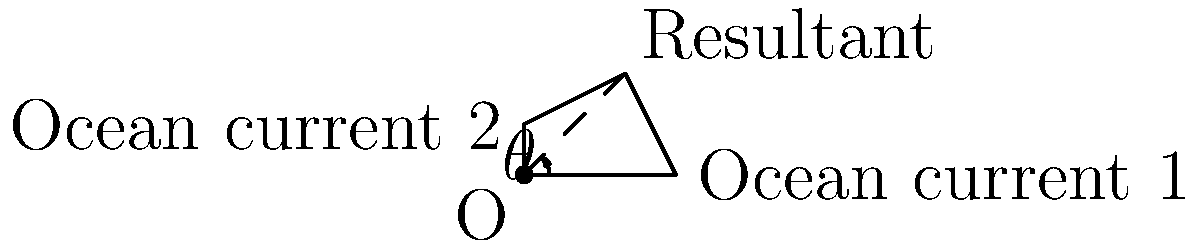Two ocean currents are affecting the migration pattern of a marine species. Current 1 has a force of 30 N due east, while Current 2 has a force of 20 N due north. Calculate the magnitude and direction of the resultant force influencing the marine animals' movement. To solve this problem, we'll use vector addition and the Pythagorean theorem:

1. Represent the currents as vectors:
   Current 1: $\vec{F_1} = 30\hat{i}$ N
   Current 2: $\vec{F_2} = 20\hat{j}$ N

2. The resultant force $\vec{R}$ is the vector sum:
   $\vec{R} = \vec{F_1} + \vec{F_2} = 30\hat{i} + 20\hat{j}$ N

3. Calculate the magnitude of the resultant force using the Pythagorean theorem:
   $|\vec{R}| = \sqrt{30^2 + 20^2} = \sqrt{1300} \approx 36.06$ N

4. Calculate the direction (angle $\theta$) using the arctangent function:
   $\theta = \tan^{-1}(\frac{20}{30}) \approx 33.69°$

5. The angle is measured from the positive x-axis (east) towards the positive y-axis (north).

Therefore, the resultant force has a magnitude of approximately 36.06 N and acts at an angle of 33.69° north of east.
Answer: 36.06 N, 33.69° north of east 